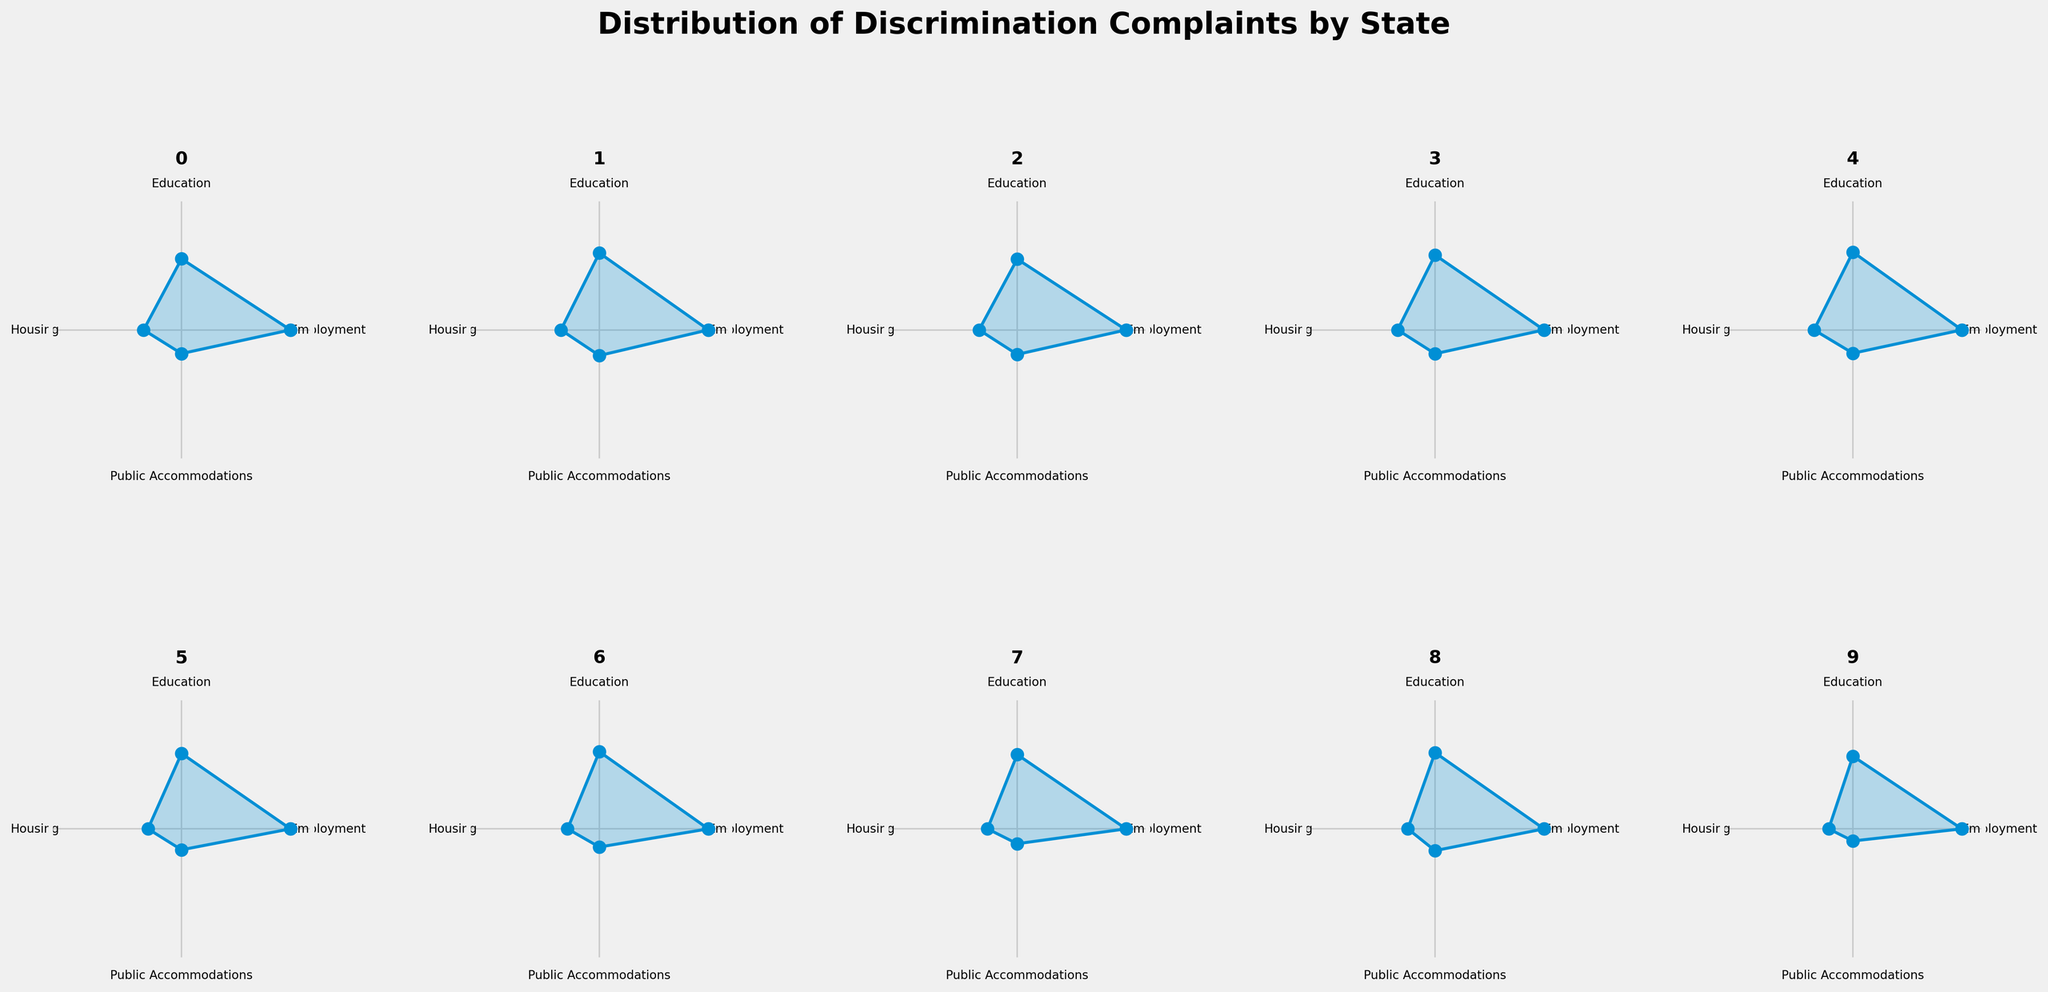What's the title of the figure? The title is usually displayed at the top of a figure in a larger and bold font. In this case, it is written at the top center of the plot.
Answer: Distribution of Discrimination Complaints by State What are the four categories shown in each subplot? The categories are labeled around the circular plots. These labels are consistent for each subplot.
Answer: Employment, Education, Housing, Public Accommodations Which state shows the highest number of complaints in the 'Employment' category? By examining each subplot, the line radiating from the center to the 'Employment' category can be compared. The longest line represents the highest number.
Answer: California Compared to Florida, how many more complaints does Texas have in the 'Public Accommodations' category? By looking at the lengths of the lines leading to 'Public Accommodations' for both states, Texas has 40, and Florida has 35 complaints. Subtracting these gives the difference.
Answer: 5 Which state has the smallest total number of complaints? The total number of complaints can be inferred from the spread of the plot lines. By comparing each subplot, the one with the shortest lines in total corresponds to the smallest number.
Answer: Michigan What is the difference in the number of 'Education' complaints between New York and Illinois? For the 'Education' category, compare the heights of the lines for New York and Illinois. New York has 130 and Illinois has 100. Subtracting these values gives the difference.
Answer: 30 In which category does North Carolina have the fewest complaints, and how many? By examining the North Carolina subplot, determine which line is the shortest and interpret the corresponding category and value.
Answer: Housing, 25 Compare the 'Housing' complaints in Ohio and Michigan. Which state has more, and by how much? Compare the length of the lines for 'Housing' in Ohio and Michigan. Ohio has 35 and Michigan has 20. Subtracting these values gives the difference.
Answer: Ohio, 15 Which state reports fewer 'Public Accommodations' complaints than 'Housing' complaints? By comparing the length of the lines for 'Public Accommodations' and 'Housing' in each state, look for the state where the line for 'Public Accommodations' is shorter.
Answer: Pennsylvania What is the average number of 'Employment' complaints among all states? Sum the 'Employment' complaints for all states and divide by the number of states. (230+170+200+160+140+130+120+110+100+90)/10 = 145
Answer: 145 